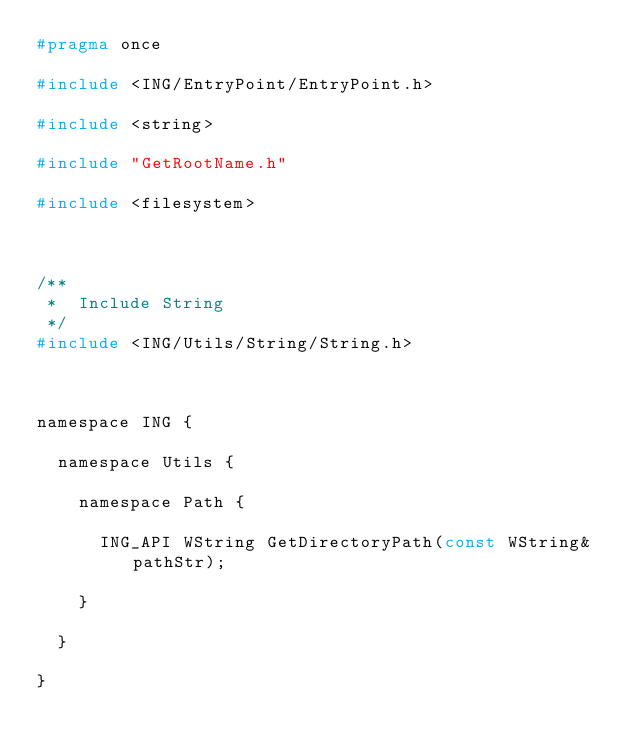<code> <loc_0><loc_0><loc_500><loc_500><_C_>#pragma once

#include <ING/EntryPoint/EntryPoint.h>

#include <string>

#include "GetRootName.h"

#include <filesystem>



/**
 *	Include String
 */
#include <ING/Utils/String/String.h>



namespace ING {

	namespace Utils {

		namespace Path {

			ING_API WString GetDirectoryPath(const WString& pathStr);

		}

	}

}</code> 